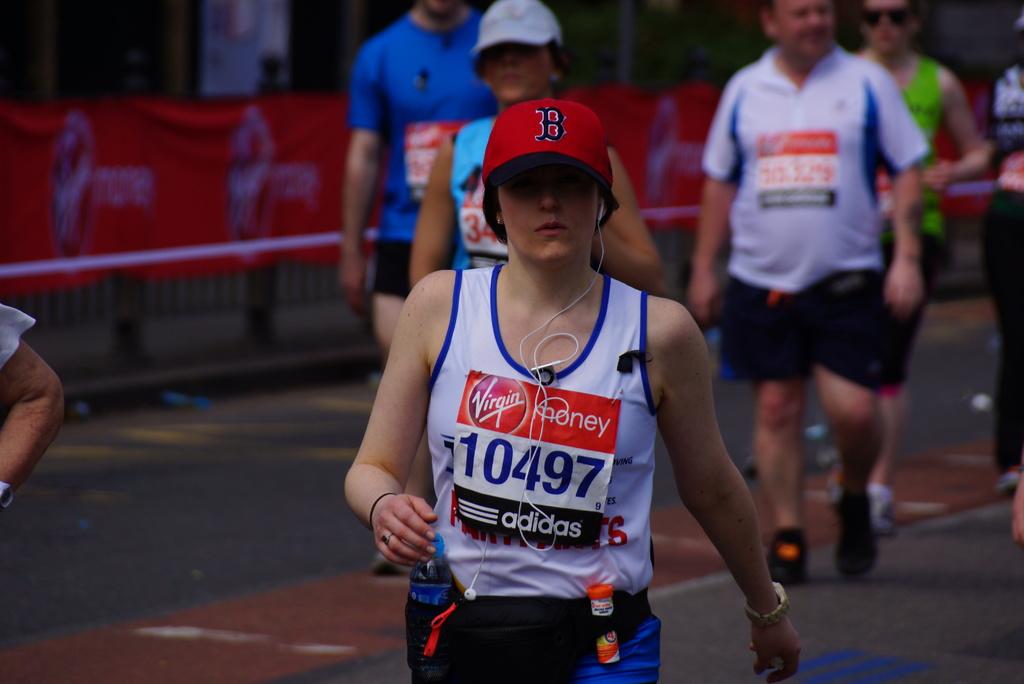What's their runner number?
Keep it short and to the point. 10497. What cell phone company is listed on the female runner's sign?
Your answer should be very brief. Virgin. 